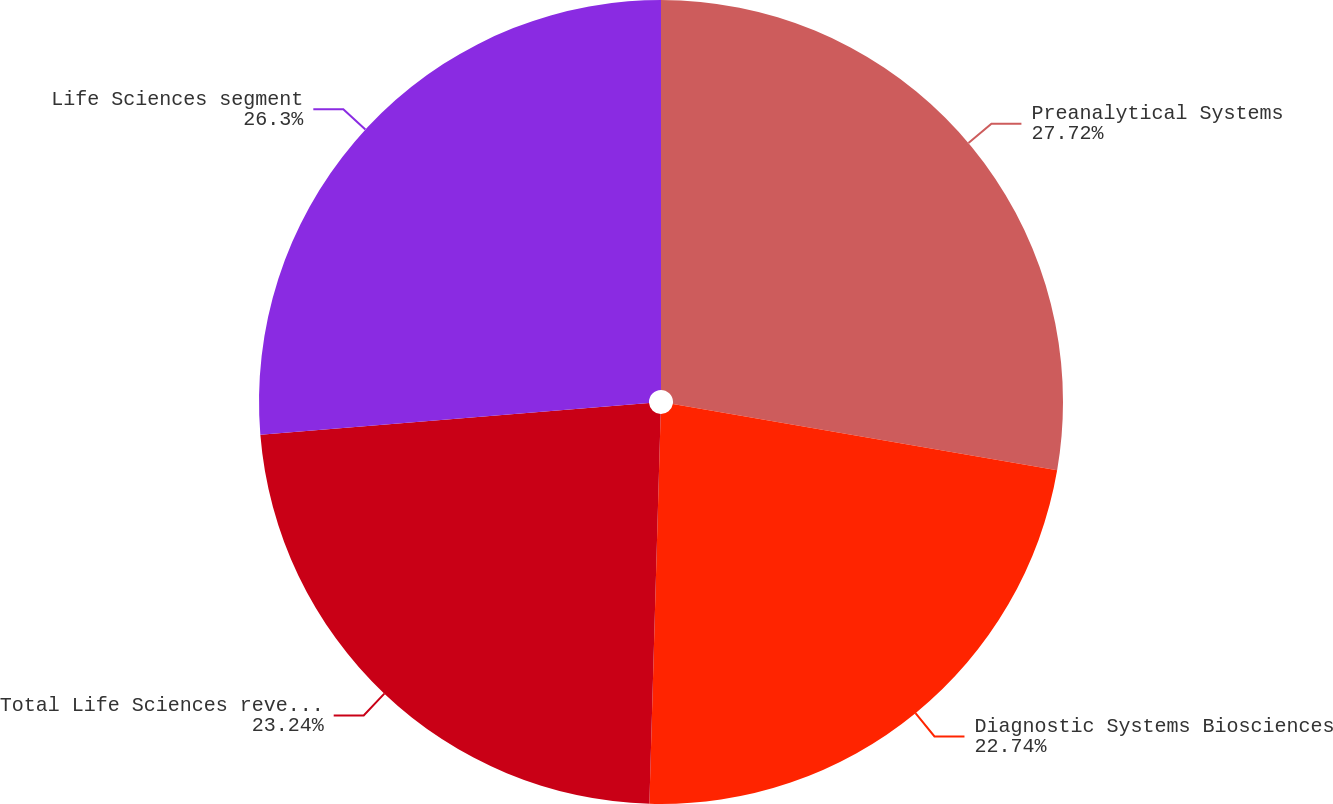<chart> <loc_0><loc_0><loc_500><loc_500><pie_chart><fcel>Preanalytical Systems<fcel>Diagnostic Systems Biosciences<fcel>Total Life Sciences revenues<fcel>Life Sciences segment<nl><fcel>27.72%<fcel>22.74%<fcel>23.24%<fcel>26.3%<nl></chart> 